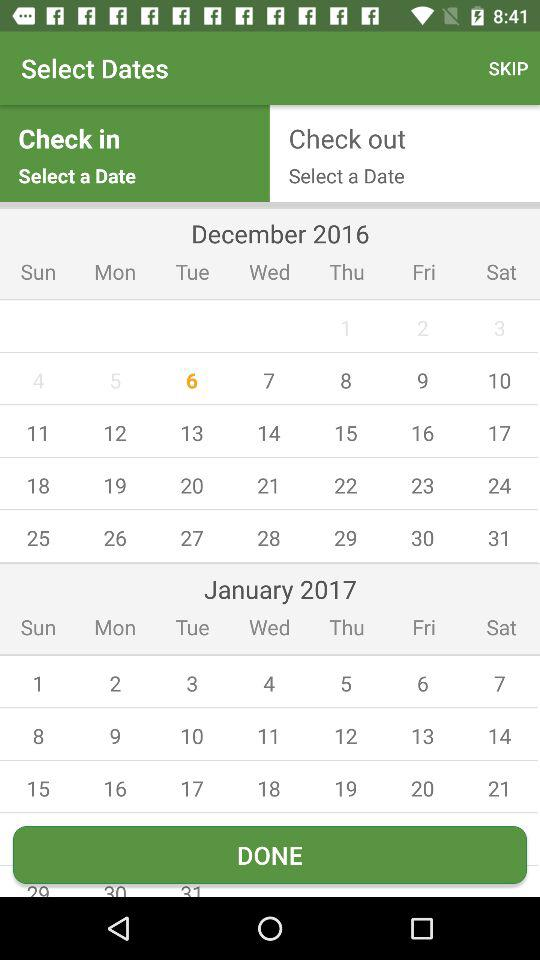Which date is selected for check out?
When the provided information is insufficient, respond with <no answer>. <no answer> 